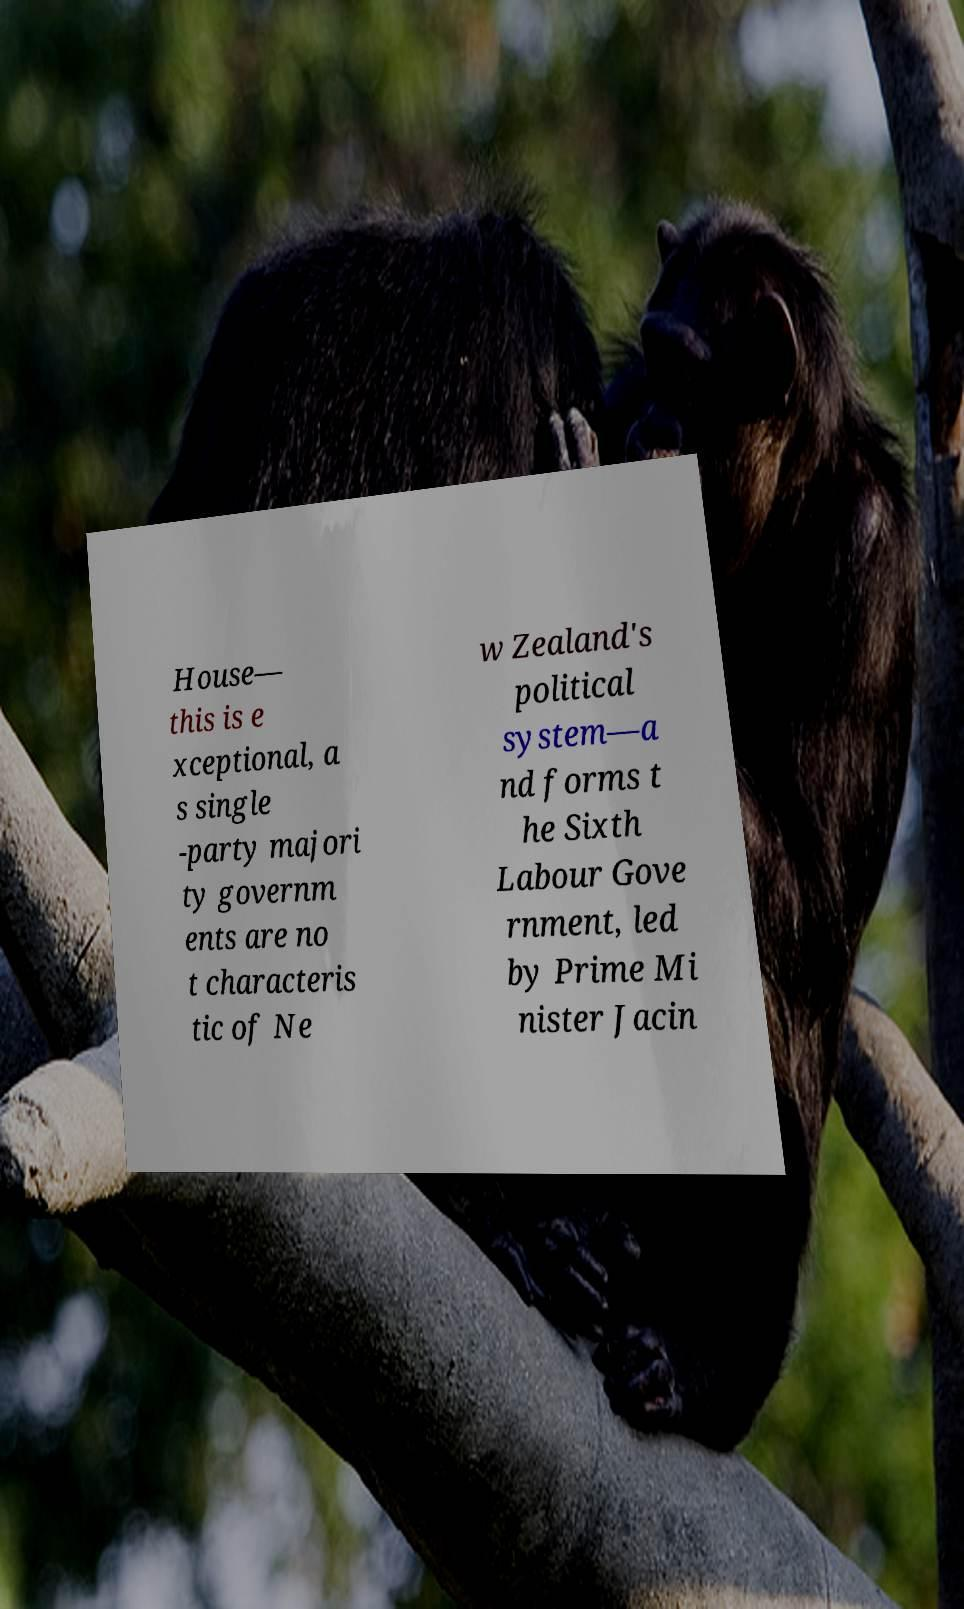I need the written content from this picture converted into text. Can you do that? House— this is e xceptional, a s single -party majori ty governm ents are no t characteris tic of Ne w Zealand's political system—a nd forms t he Sixth Labour Gove rnment, led by Prime Mi nister Jacin 